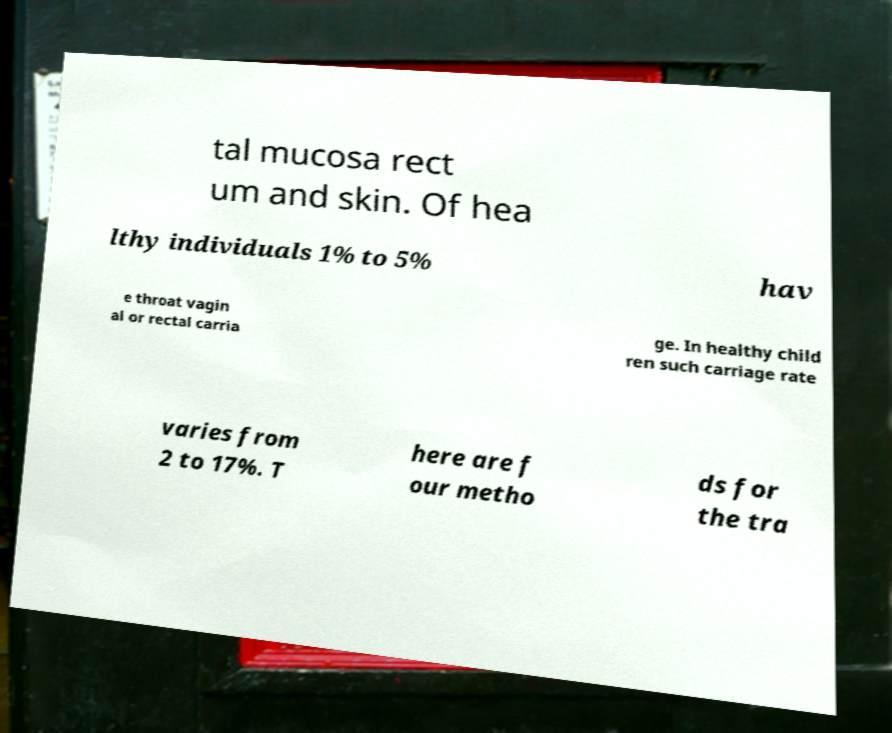Can you read and provide the text displayed in the image?This photo seems to have some interesting text. Can you extract and type it out for me? tal mucosa rect um and skin. Of hea lthy individuals 1% to 5% hav e throat vagin al or rectal carria ge. In healthy child ren such carriage rate varies from 2 to 17%. T here are f our metho ds for the tra 